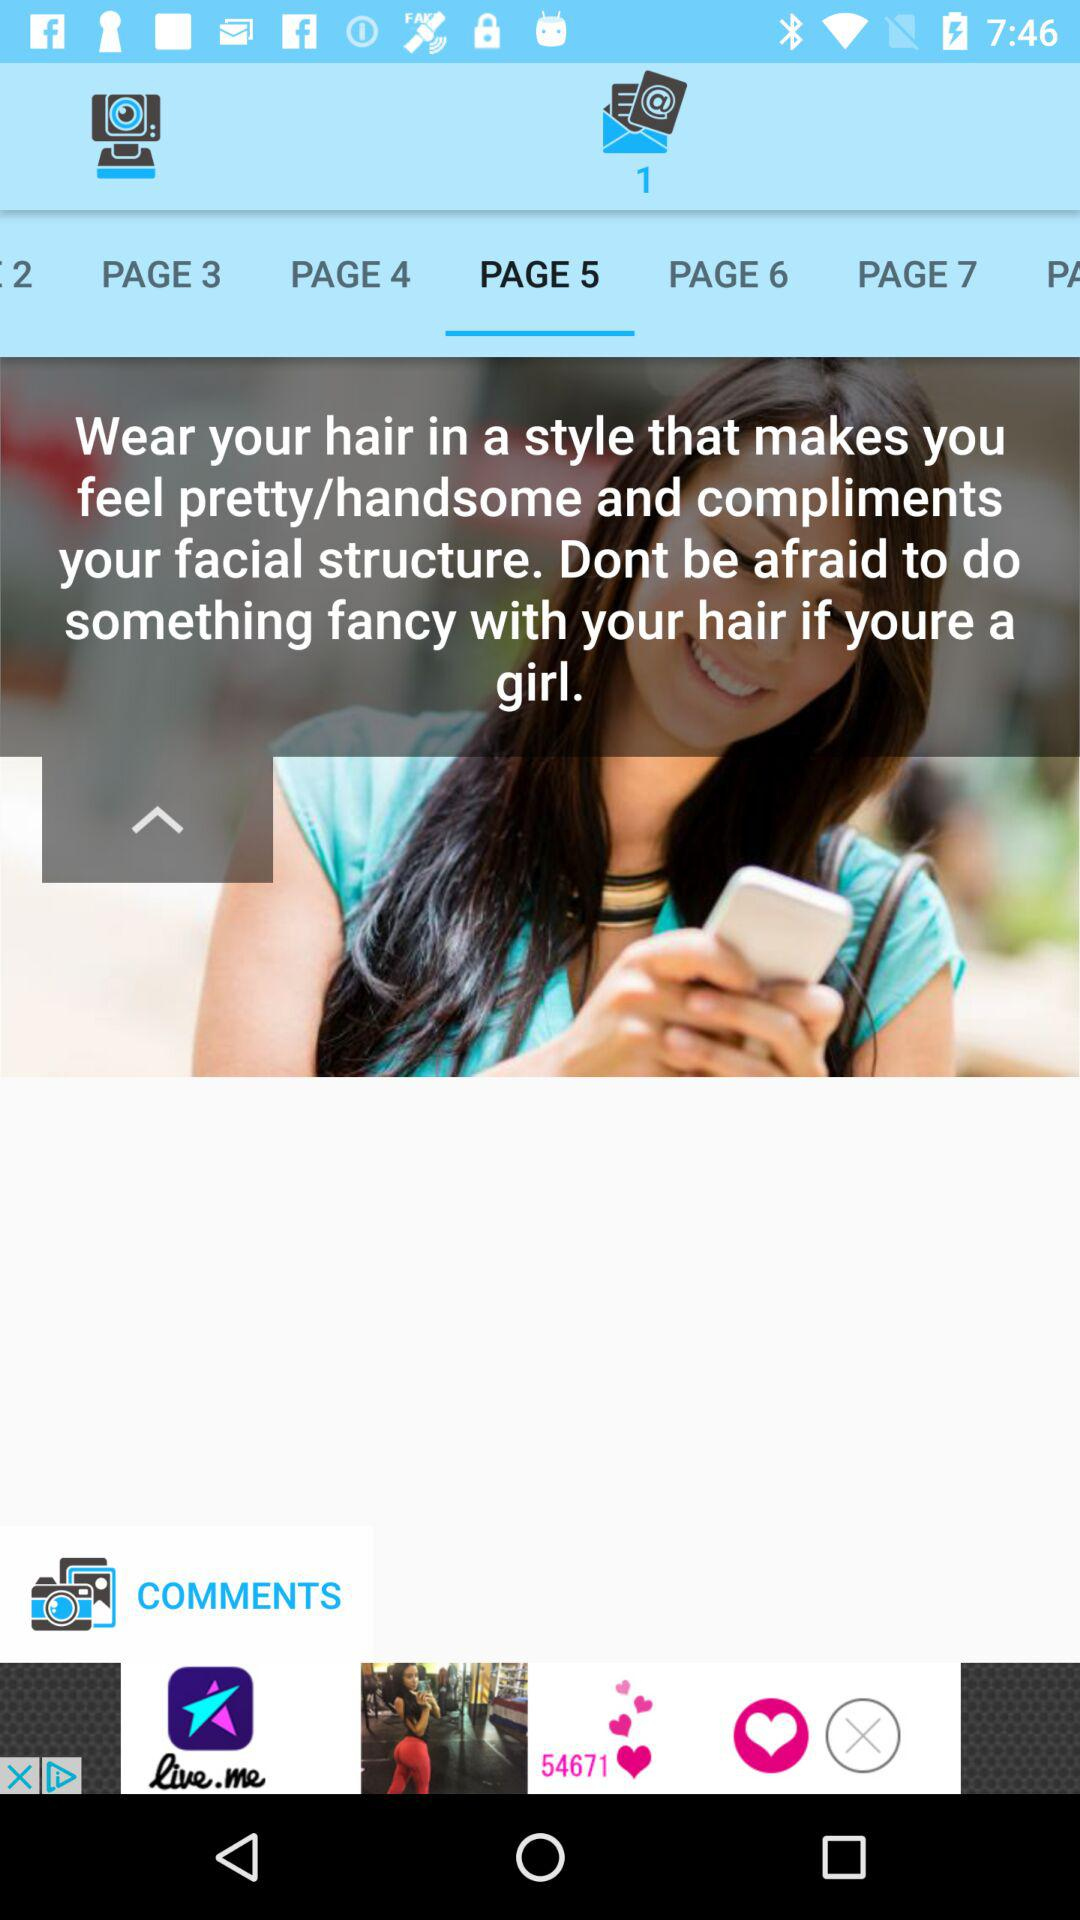Which is the current page? The current page is "PAGE 5". 